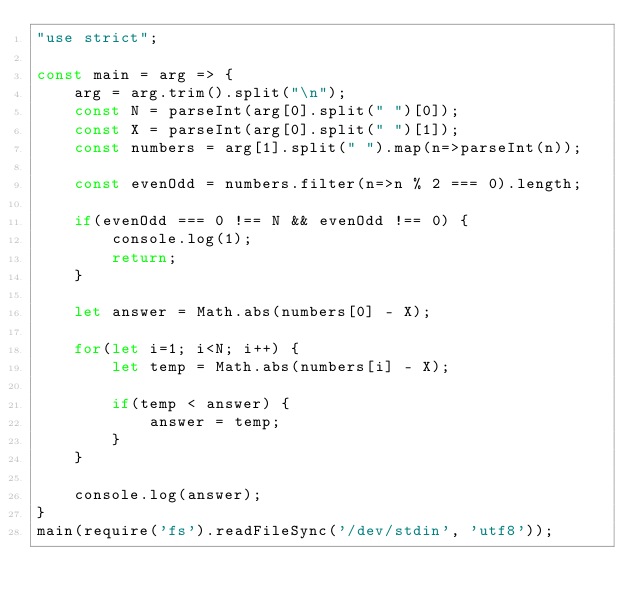<code> <loc_0><loc_0><loc_500><loc_500><_JavaScript_>"use strict";
    
const main = arg => {
    arg = arg.trim().split("\n");
    const N = parseInt(arg[0].split(" ")[0]);
    const X = parseInt(arg[0].split(" ")[1]);
    const numbers = arg[1].split(" ").map(n=>parseInt(n));
    
    const evenOdd = numbers.filter(n=>n % 2 === 0).length;
    
    if(evenOdd === 0 !== N && evenOdd !== 0) {
        console.log(1);
        return;
    }
    
    let answer = Math.abs(numbers[0] - X);
    
    for(let i=1; i<N; i++) {
        let temp = Math.abs(numbers[i] - X);
        
        if(temp < answer) {
            answer = temp;
        }
    }
    
    console.log(answer);
}
main(require('fs').readFileSync('/dev/stdin', 'utf8'));</code> 